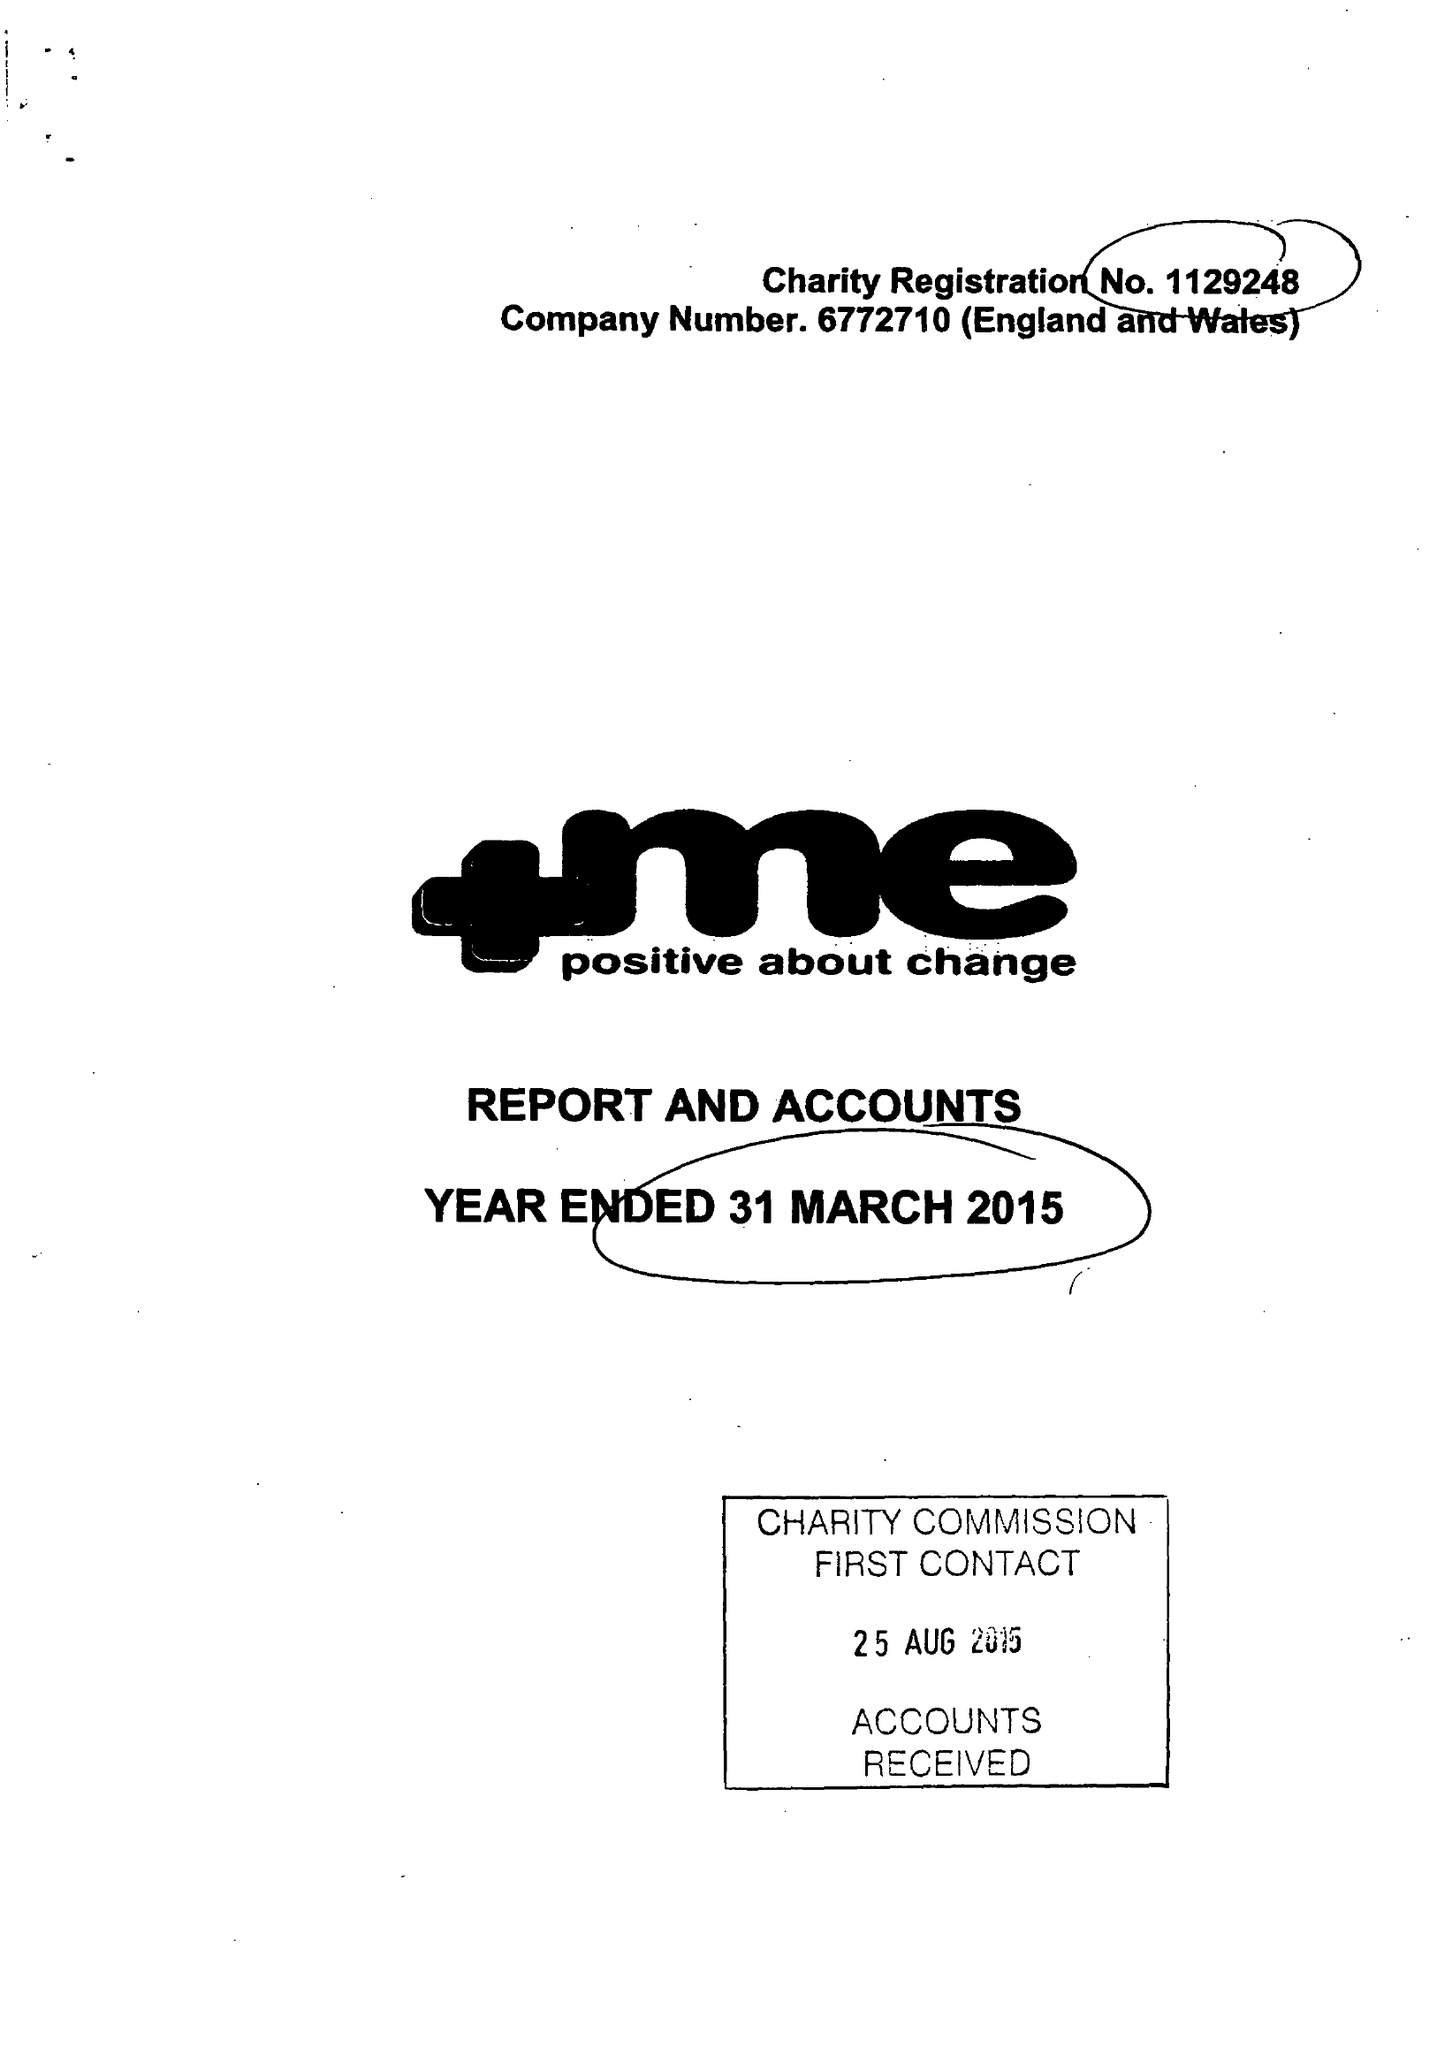What is the value for the income_annually_in_british_pounds?
Answer the question using a single word or phrase. 104003.00 